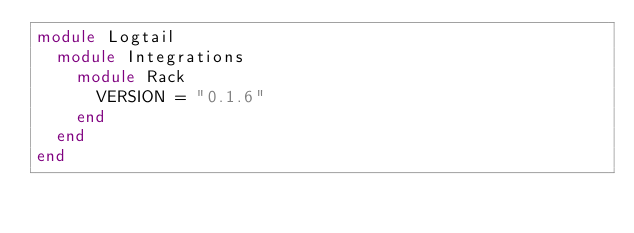<code> <loc_0><loc_0><loc_500><loc_500><_Ruby_>module Logtail
  module Integrations
    module Rack
      VERSION = "0.1.6"
    end
  end
end
</code> 